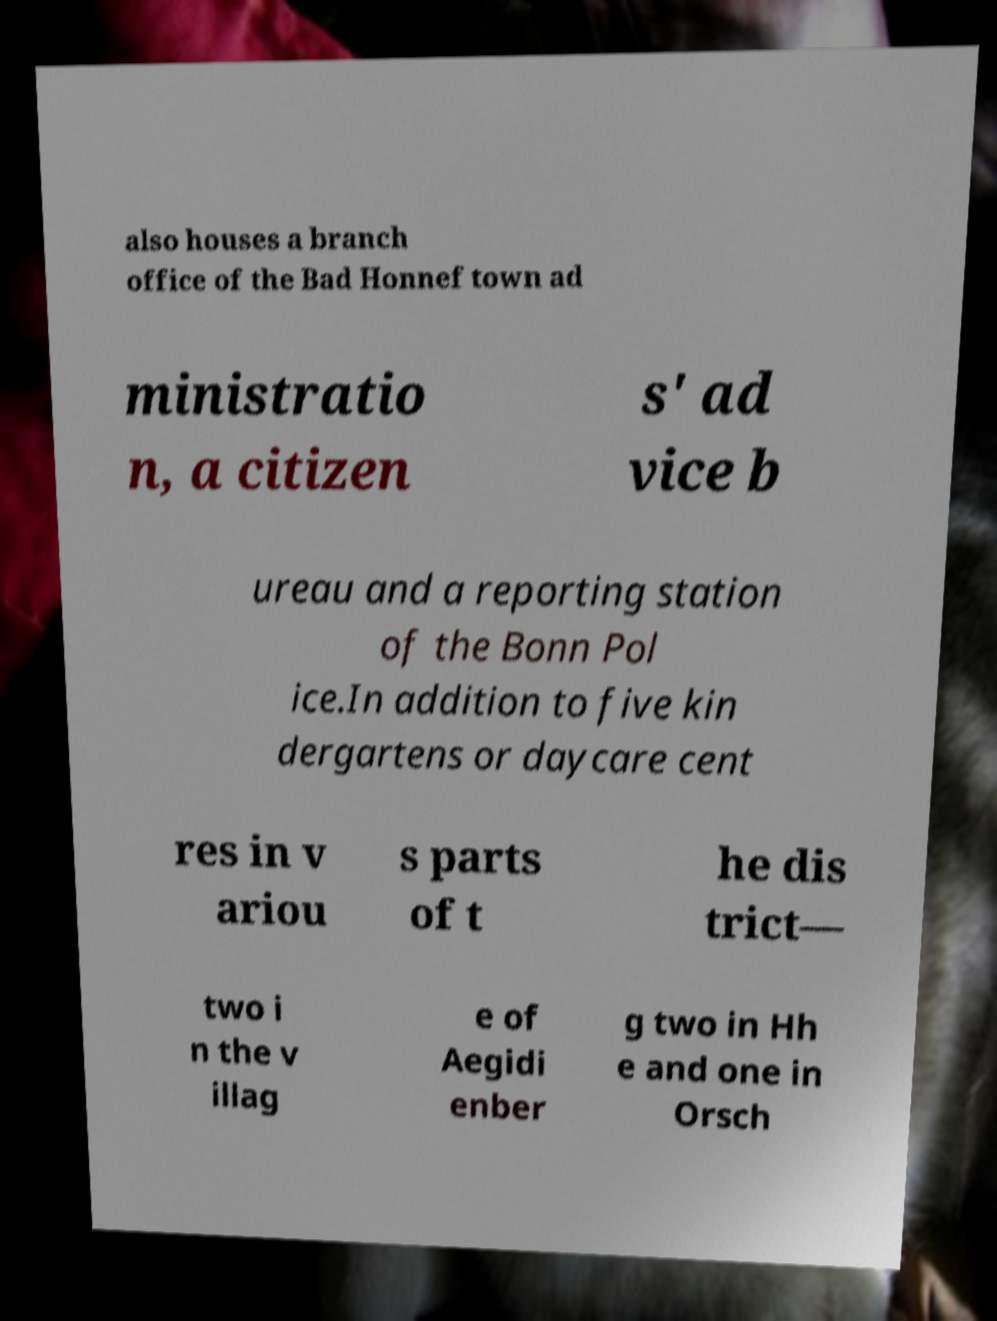There's text embedded in this image that I need extracted. Can you transcribe it verbatim? also houses a branch office of the Bad Honnef town ad ministratio n, a citizen s' ad vice b ureau and a reporting station of the Bonn Pol ice.In addition to five kin dergartens or daycare cent res in v ariou s parts of t he dis trict— two i n the v illag e of Aegidi enber g two in Hh e and one in Orsch 